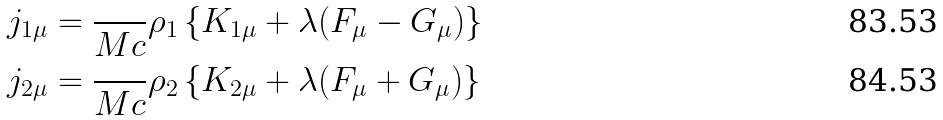<formula> <loc_0><loc_0><loc_500><loc_500>j _ { 1 \mu } & = \frac { } { M c } \rho _ { 1 } \left \{ K _ { 1 \mu } + \lambda ( F _ { \mu } - G _ { \mu } ) \right \} \\ j _ { 2 \mu } & = \frac { } { M c } \rho _ { 2 } \left \{ K _ { 2 \mu } + \lambda ( F _ { \mu } + G _ { \mu } ) \right \}</formula> 